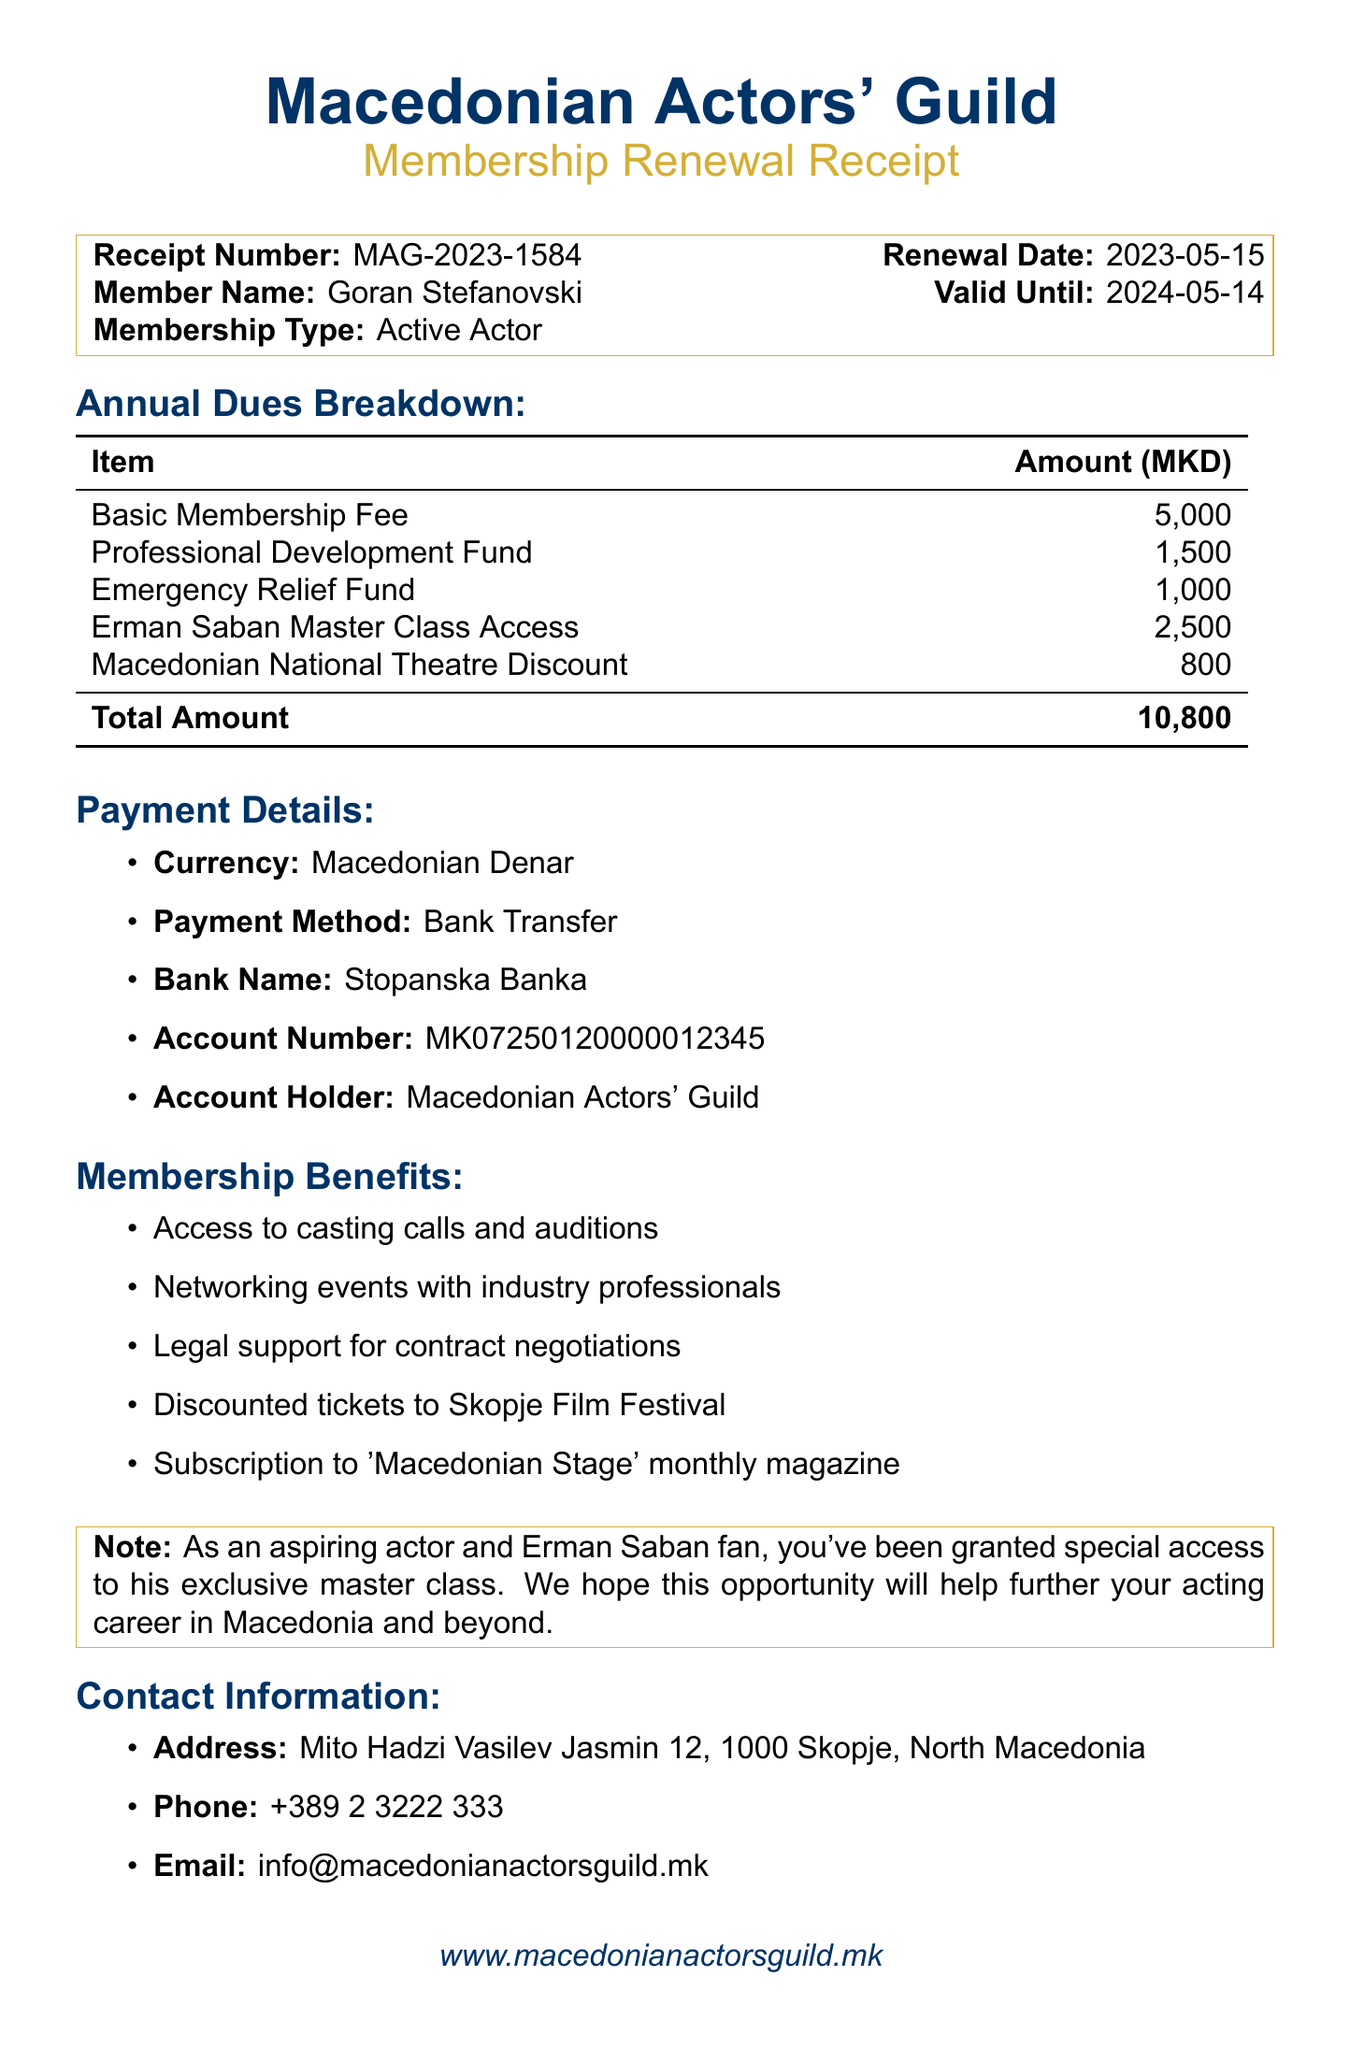What is the receipt number? The receipt number is listed prominently in the document under the member's details.
Answer: MAG-2023-1584 Who is the member? The member's name is specified near the top of the document.
Answer: Goran Stefanovski What is the total amount due? The total amount is calculated and stated at the end of the annual dues breakdown table.
Answer: 10,800 What is the renewal date? The renewal date is provided alongside the receipt number and member name.
Answer: 2023-05-15 What fund contributes 1,500 MKD? The breakdown lists various funds and their amounts, including one that contributes 1,500 MKD.
Answer: Professional Development Fund What is the duration of the membership validity? The validity period is mentioned right next to the renewal date in the member details section.
Answer: 2024-05-14 What payment method was used? The document lists the payment method separately in the payment details section.
Answer: Bank Transfer What benefit includes discounted tickets? Benefits are listed that showcase various advantages of membership, including ticket discounts.
Answer: Discounted tickets to Skopje Film Festival What is the address of the guild office? The address is clearly stated in the contact information section of the document.
Answer: Mito Hadzi Vasilev Jasmin 12, 1000 Skopje, North Macedonia 